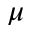Convert formula to latex. <formula><loc_0><loc_0><loc_500><loc_500>\mu</formula> 